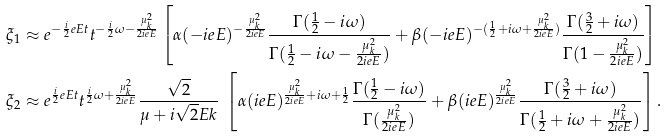<formula> <loc_0><loc_0><loc_500><loc_500>& \xi _ { 1 } \approx e ^ { - \frac { i } { 2 } e E t } t ^ { - \frac { i } { 2 } \omega - \frac { \mu _ { k } ^ { 2 } } { 2 i e E } } \left [ \alpha ( - i e E ) ^ { - \frac { \mu _ { k } ^ { 2 } } { 2 i e E } } \frac { \Gamma ( \frac { 1 } { 2 } - i \omega ) } { \Gamma ( \frac { 1 } { 2 } - i \omega - \frac { \mu _ { k } ^ { 2 } } { 2 i e E } ) } + \beta ( - i e E ) ^ { - ( \frac { 1 } { 2 } + i \omega + \frac { \mu _ { k } ^ { 2 } } { 2 i e E } ) } \frac { \Gamma ( \frac { 3 } { 2 } + i \omega ) } { \Gamma ( 1 - \frac { \mu _ { k } ^ { 2 } } { 2 i e E } ) } \right ] \\ & \xi _ { 2 } \approx e ^ { \frac { i } { 2 } e E t } t ^ { \frac { i } { 2 } \omega + \frac { \mu _ { k } ^ { 2 } } { 2 i e E } } \frac { \sqrt { 2 } } { \mu + i \sqrt { 2 } E k } \ \left [ \alpha ( i e E ) ^ { \frac { \mu _ { k } ^ { 2 } } { 2 i e E } + i \omega + \frac { 1 } { 2 } } \frac { \Gamma ( \frac { 1 } { 2 } - i \omega ) } { \Gamma ( \frac { \mu _ { k } ^ { 2 } } { 2 i e E } ) } + \beta ( i e E ) ^ { \frac { \mu _ { k } ^ { 2 } } { 2 i e E } } \frac { \Gamma ( \frac { 3 } { 2 } + i \omega ) } { \Gamma ( \frac { 1 } { 2 } + i \omega + \frac { \mu _ { k } ^ { 2 } } { 2 i e E } ) } \right ] .</formula> 